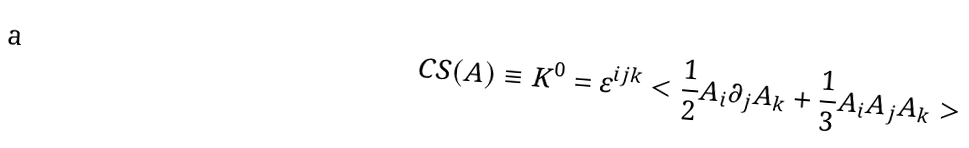<formula> <loc_0><loc_0><loc_500><loc_500>C S ( A ) \equiv K ^ { 0 } = \varepsilon ^ { i j k } < \frac { 1 } { 2 } A _ { i } \partial _ { j } A _ { k } + \frac { 1 } { 3 } A _ { i } A _ { j } A _ { k } ></formula> 